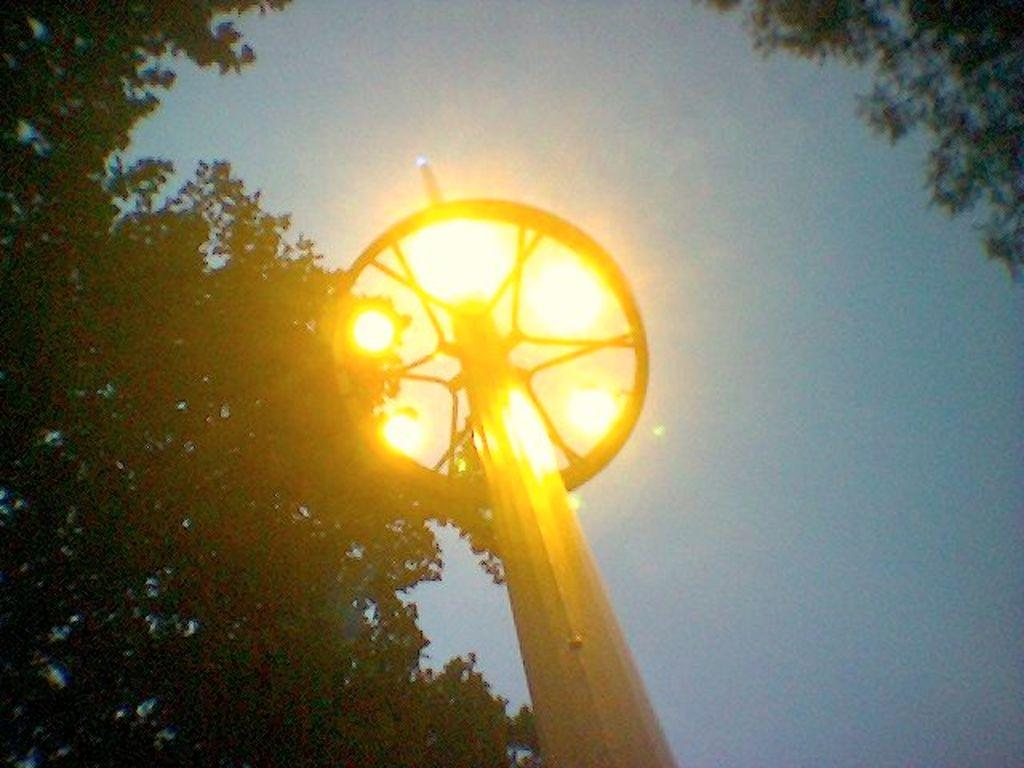What is the main object in the center of the image? There is a pole in the center of the image. What is attached to the pole? There are lights on the pole. What type of natural elements can be seen in the image? Trees are visible in the image. What is visible in the background of the image? The sky is visible in the image. What type of collar can be seen on the farm animals in the image? There are no farm animals or collars present in the image. How many matches are visible on the pole in the image? There are no matches present in the image; only lights are attached to the pole. 